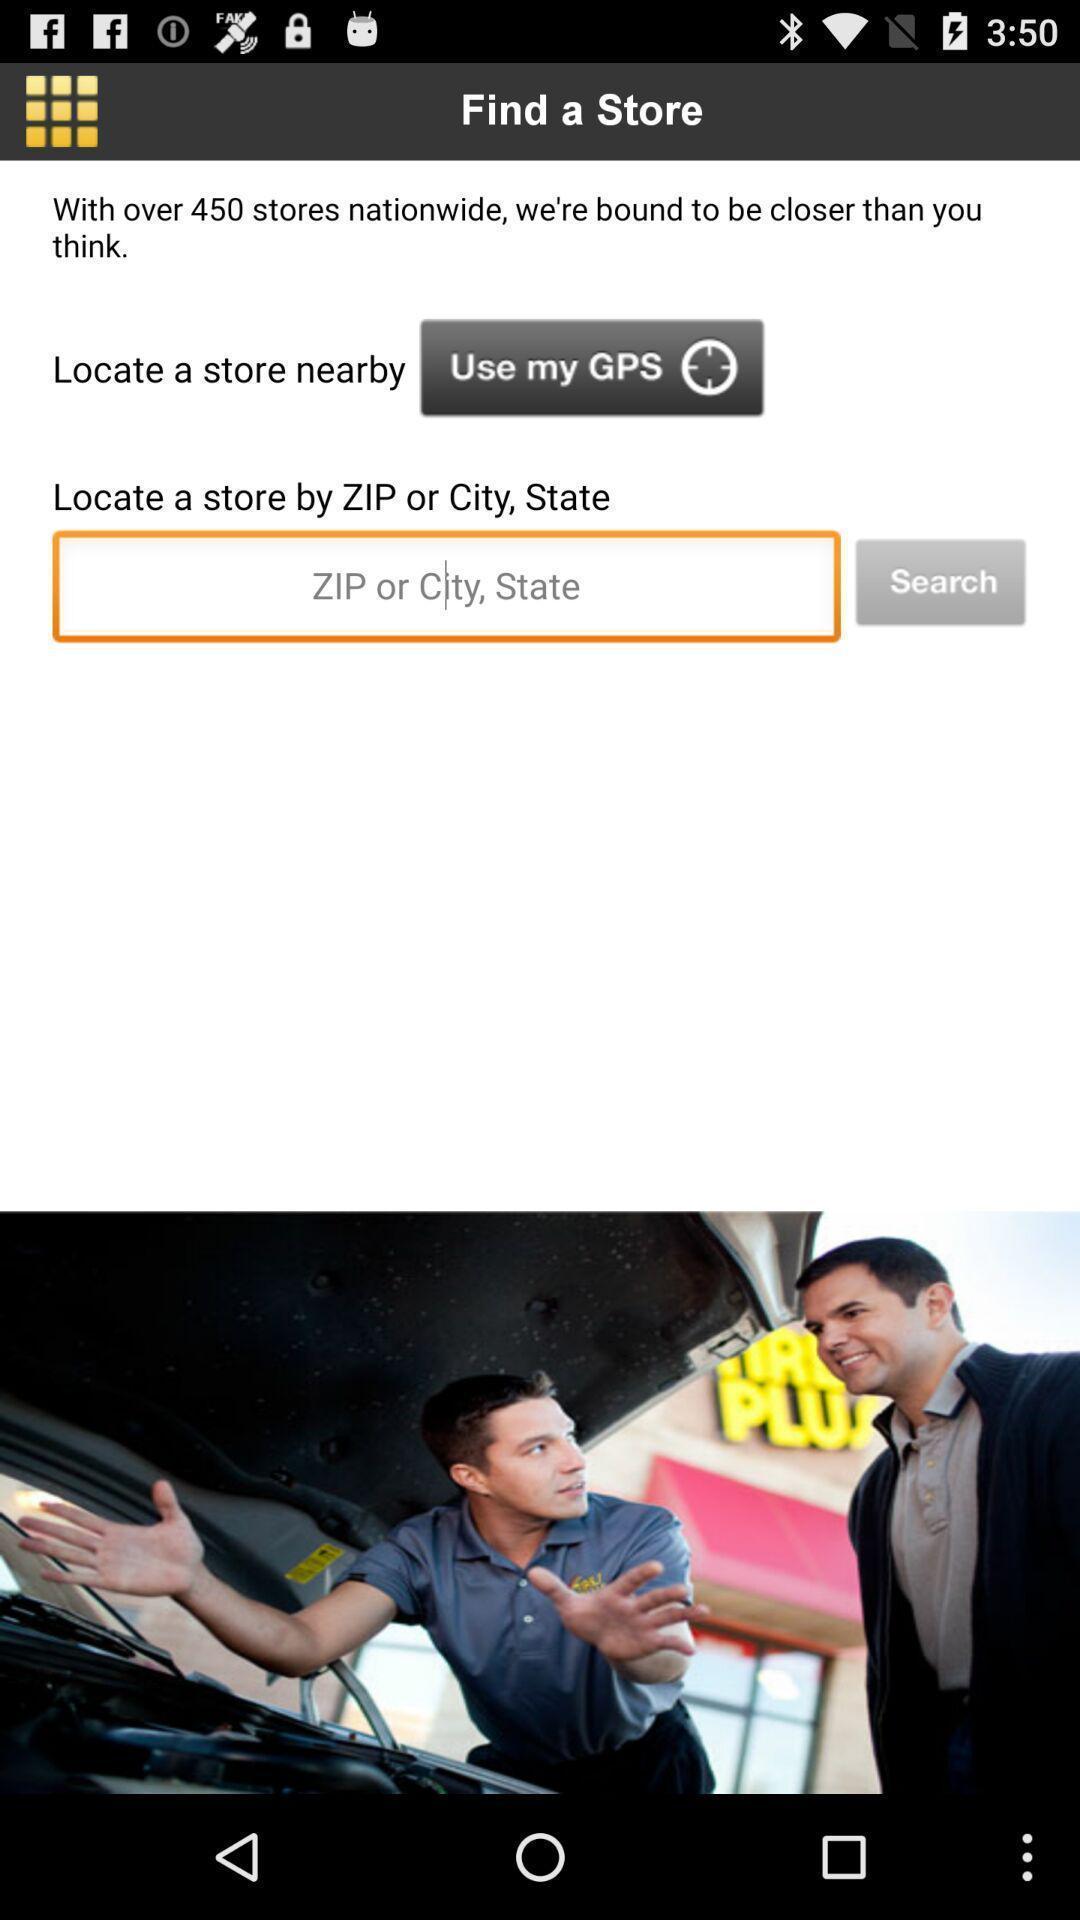Tell me what you see in this picture. Screen page displaying information in navigation application. 